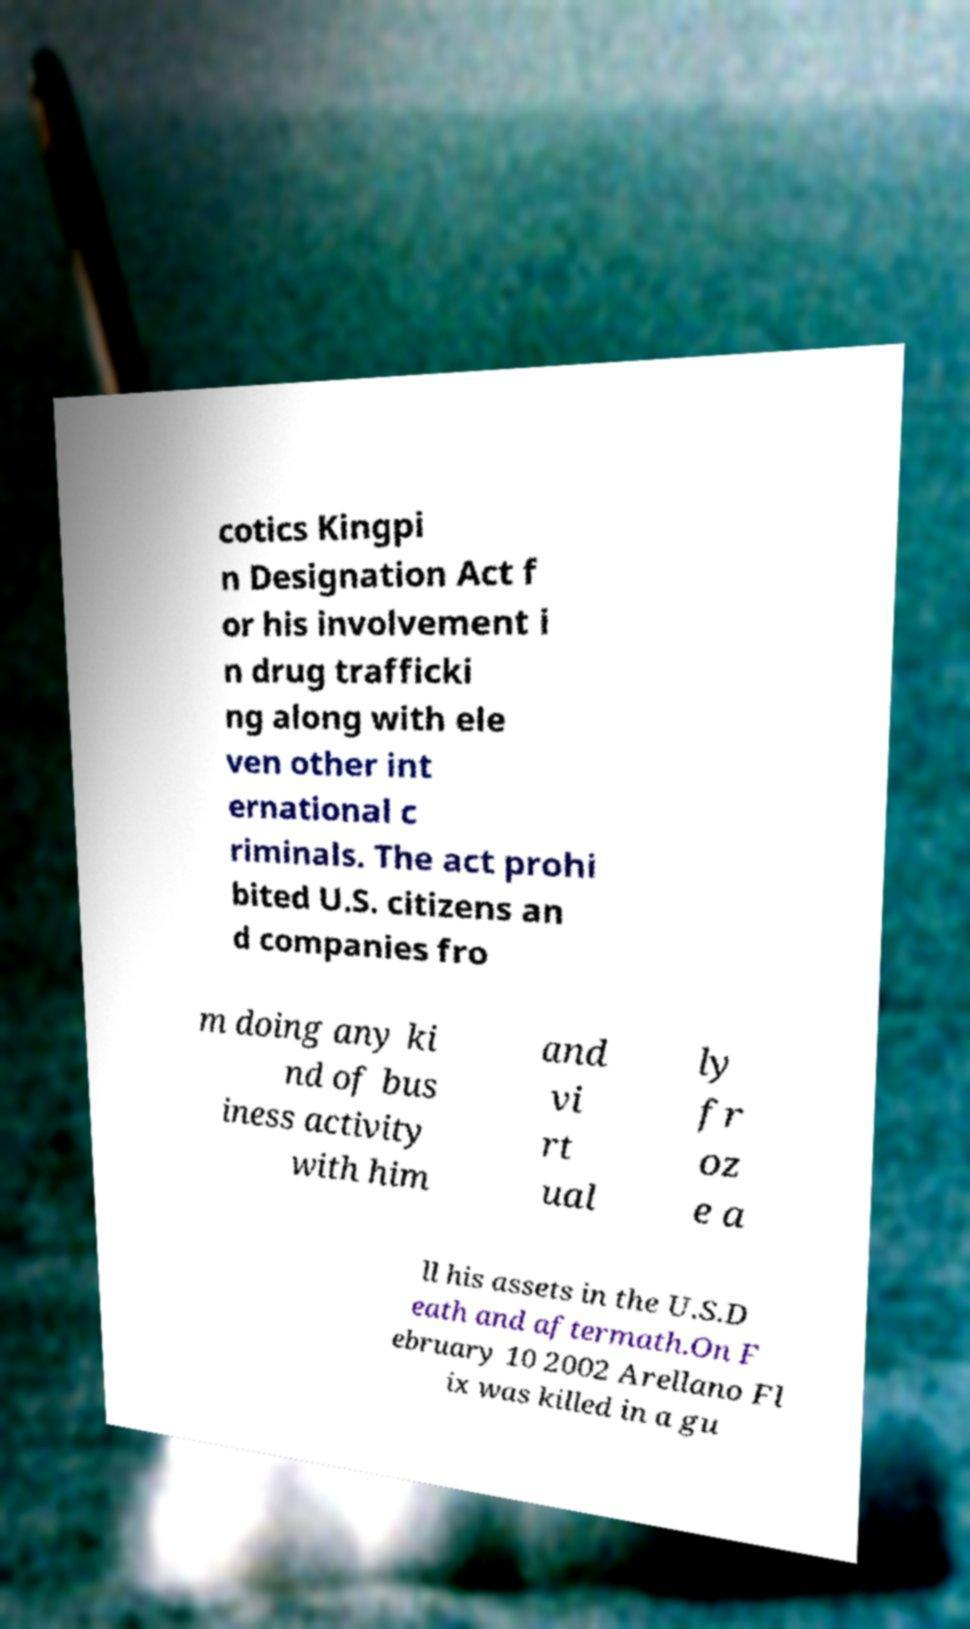Can you read and provide the text displayed in the image?This photo seems to have some interesting text. Can you extract and type it out for me? cotics Kingpi n Designation Act f or his involvement i n drug trafficki ng along with ele ven other int ernational c riminals. The act prohi bited U.S. citizens an d companies fro m doing any ki nd of bus iness activity with him and vi rt ual ly fr oz e a ll his assets in the U.S.D eath and aftermath.On F ebruary 10 2002 Arellano Fl ix was killed in a gu 